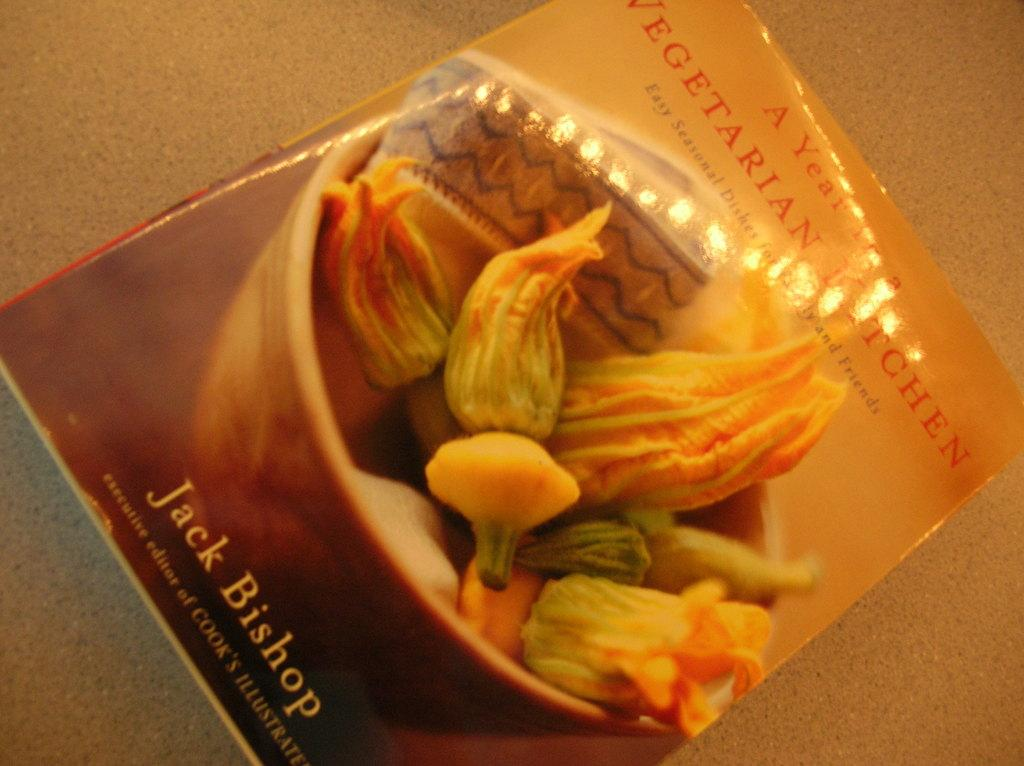What is present in the image that contains both images and text? There is a poster in the image that contains images and text. Where is the poster located in the image? The poster is placed on the ground in the image. What type of pets are visible in the image? There are no pets visible in the image; it only contains a poster with images and text. What is the reason for the poster's existence in the image? The reason for the poster's existence in the image cannot be determined from the provided facts. 